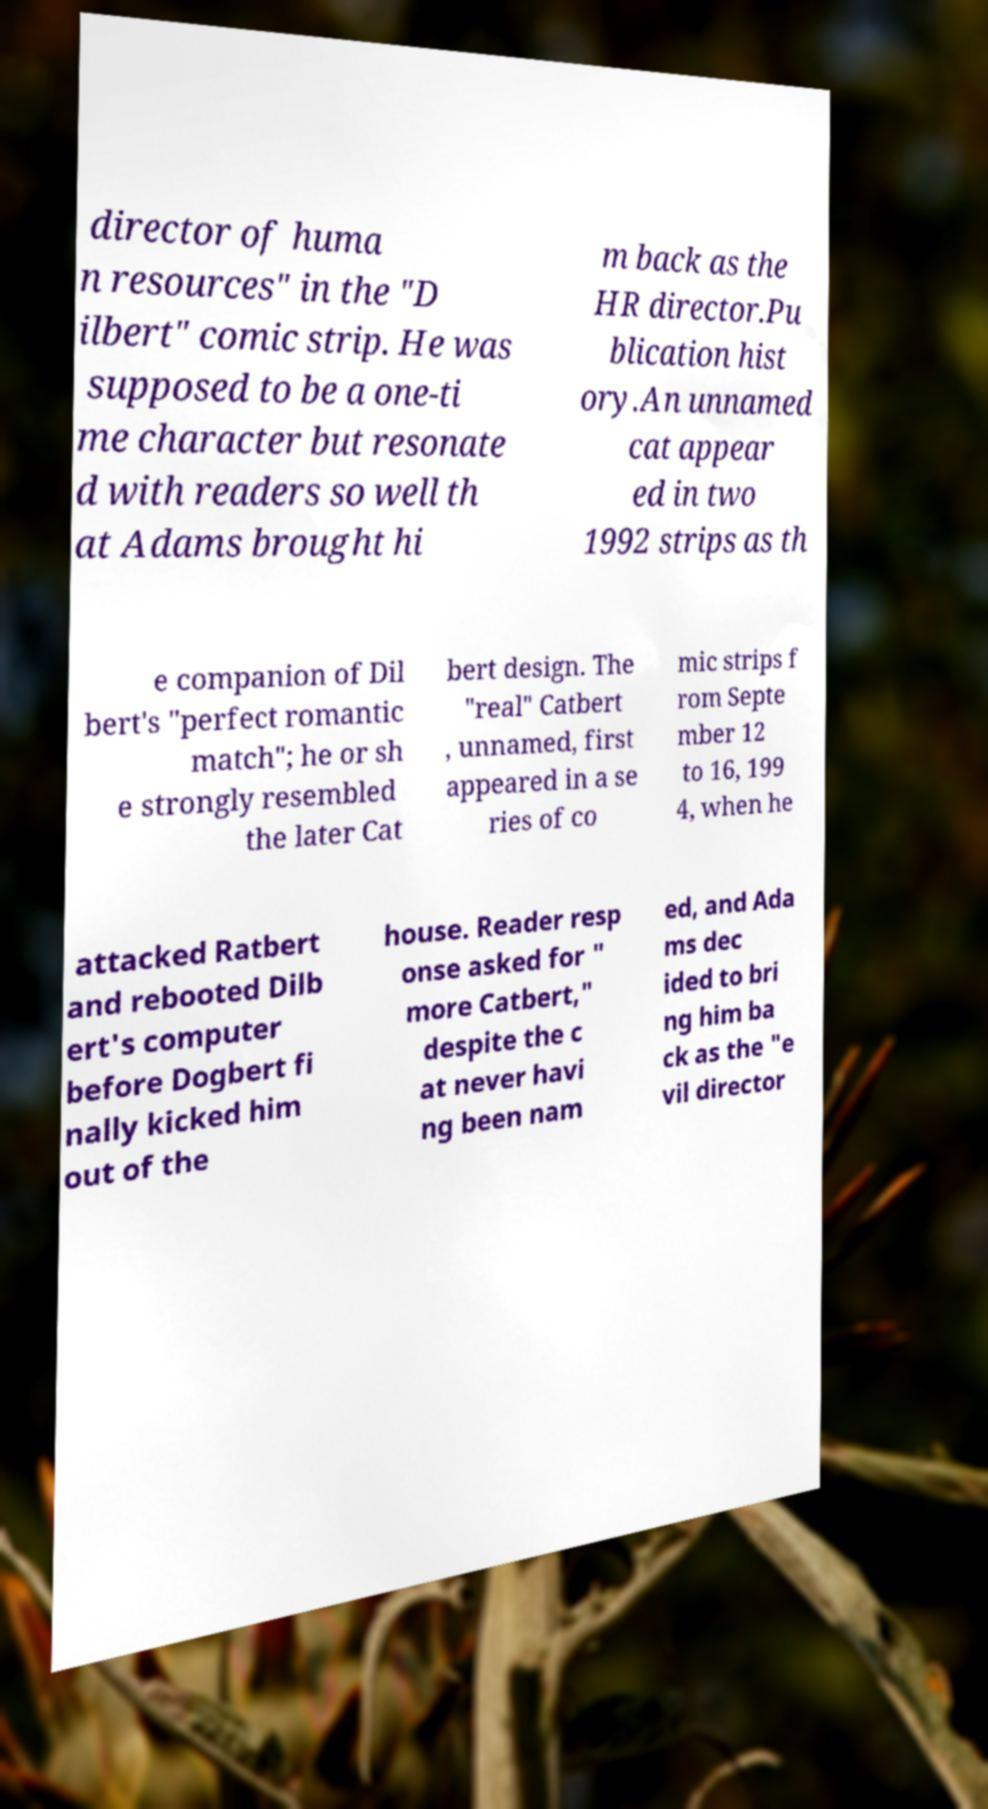Can you accurately transcribe the text from the provided image for me? director of huma n resources" in the "D ilbert" comic strip. He was supposed to be a one-ti me character but resonate d with readers so well th at Adams brought hi m back as the HR director.Pu blication hist ory.An unnamed cat appear ed in two 1992 strips as th e companion of Dil bert's "perfect romantic match"; he or sh e strongly resembled the later Cat bert design. The "real" Catbert , unnamed, first appeared in a se ries of co mic strips f rom Septe mber 12 to 16, 199 4, when he attacked Ratbert and rebooted Dilb ert's computer before Dogbert fi nally kicked him out of the house. Reader resp onse asked for " more Catbert," despite the c at never havi ng been nam ed, and Ada ms dec ided to bri ng him ba ck as the "e vil director 